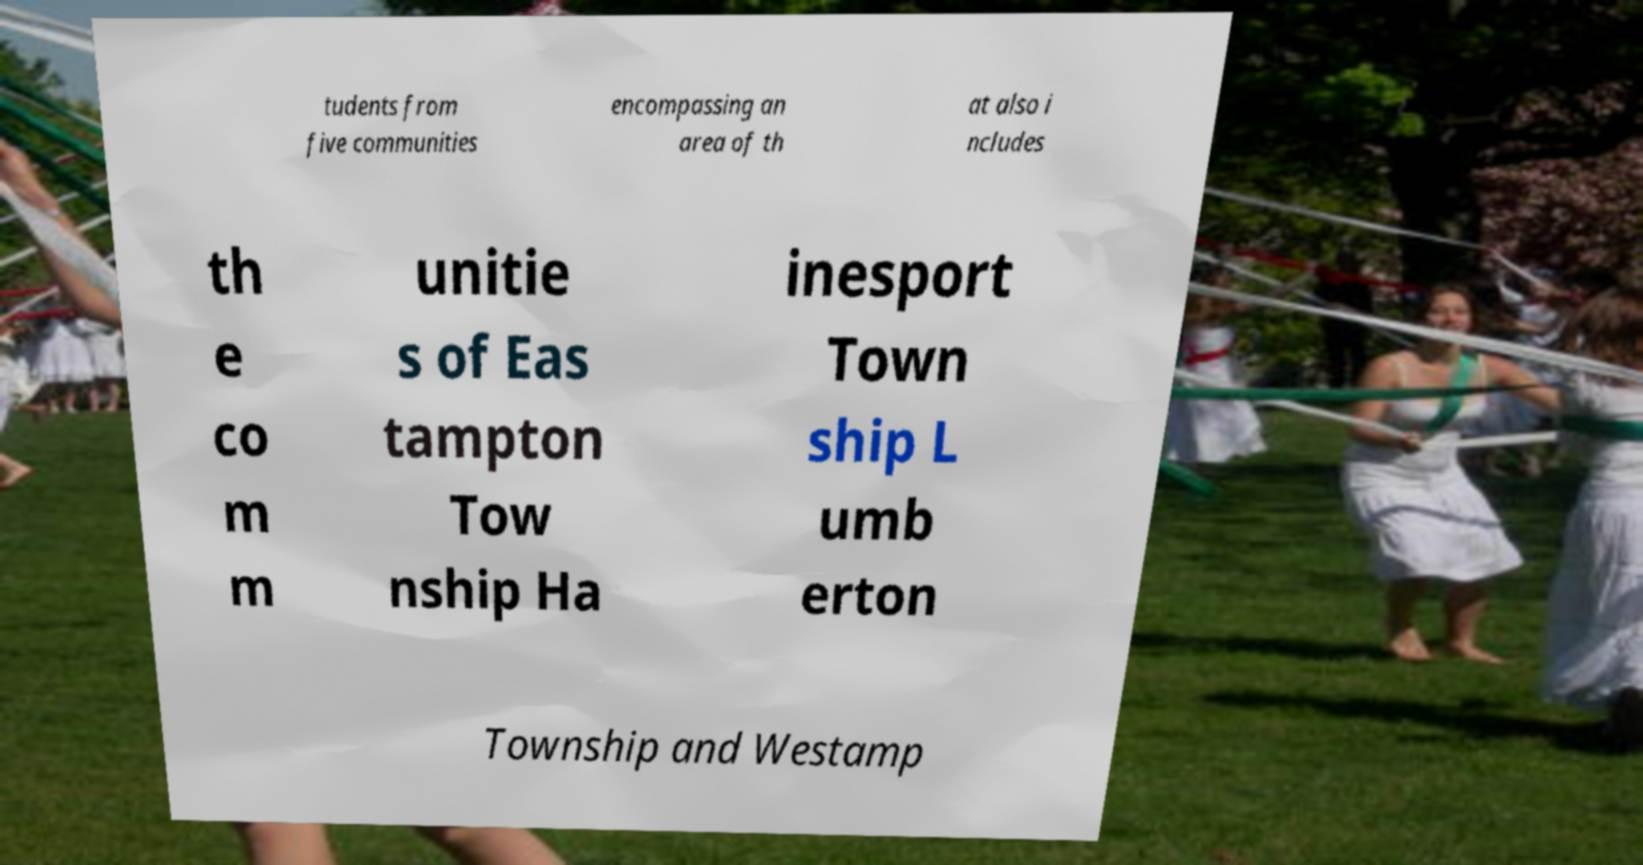Please read and relay the text visible in this image. What does it say? tudents from five communities encompassing an area of th at also i ncludes th e co m m unitie s of Eas tampton Tow nship Ha inesport Town ship L umb erton Township and Westamp 